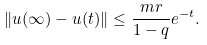<formula> <loc_0><loc_0><loc_500><loc_500>\| u ( \infty ) - u ( t ) \| \leq \frac { m r } { 1 - q } e ^ { - t } .</formula> 